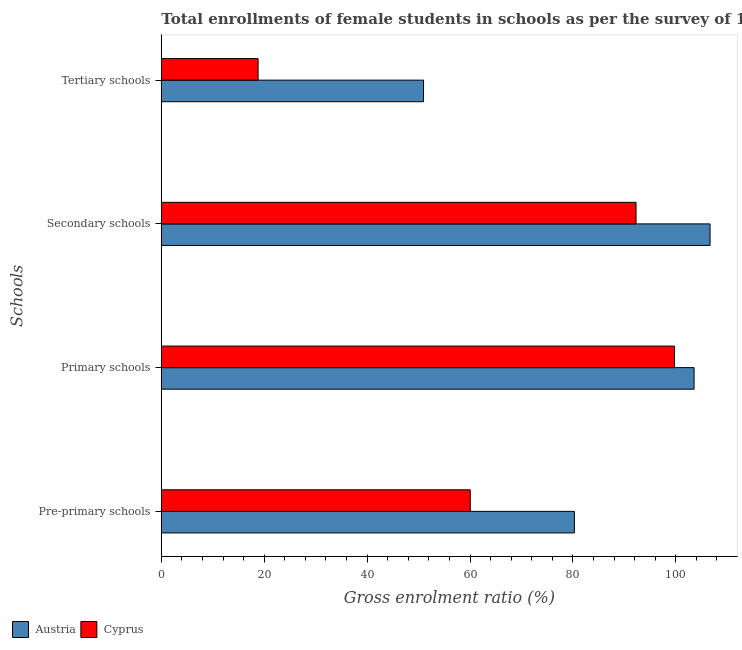How many different coloured bars are there?
Ensure brevity in your answer.  2. Are the number of bars per tick equal to the number of legend labels?
Give a very brief answer. Yes. Are the number of bars on each tick of the Y-axis equal?
Offer a terse response. Yes. What is the label of the 1st group of bars from the top?
Keep it short and to the point. Tertiary schools. What is the gross enrolment ratio(female) in tertiary schools in Cyprus?
Keep it short and to the point. 18.81. Across all countries, what is the maximum gross enrolment ratio(female) in tertiary schools?
Your answer should be very brief. 50.97. Across all countries, what is the minimum gross enrolment ratio(female) in pre-primary schools?
Your response must be concise. 60.05. In which country was the gross enrolment ratio(female) in tertiary schools minimum?
Your answer should be compact. Cyprus. What is the total gross enrolment ratio(female) in tertiary schools in the graph?
Your answer should be very brief. 69.78. What is the difference between the gross enrolment ratio(female) in secondary schools in Austria and that in Cyprus?
Provide a short and direct response. 14.38. What is the difference between the gross enrolment ratio(female) in primary schools in Austria and the gross enrolment ratio(female) in secondary schools in Cyprus?
Provide a short and direct response. 11.28. What is the average gross enrolment ratio(female) in pre-primary schools per country?
Keep it short and to the point. 70.17. What is the difference between the gross enrolment ratio(female) in primary schools and gross enrolment ratio(female) in pre-primary schools in Austria?
Offer a terse response. 23.26. What is the ratio of the gross enrolment ratio(female) in secondary schools in Cyprus to that in Austria?
Provide a short and direct response. 0.87. Is the gross enrolment ratio(female) in tertiary schools in Austria less than that in Cyprus?
Your response must be concise. No. Is the difference between the gross enrolment ratio(female) in secondary schools in Austria and Cyprus greater than the difference between the gross enrolment ratio(female) in pre-primary schools in Austria and Cyprus?
Make the answer very short. No. What is the difference between the highest and the second highest gross enrolment ratio(female) in pre-primary schools?
Your answer should be very brief. 20.24. What is the difference between the highest and the lowest gross enrolment ratio(female) in pre-primary schools?
Offer a very short reply. 20.24. What does the 1st bar from the top in Primary schools represents?
Provide a succinct answer. Cyprus. What does the 1st bar from the bottom in Tertiary schools represents?
Provide a succinct answer. Austria. Is it the case that in every country, the sum of the gross enrolment ratio(female) in pre-primary schools and gross enrolment ratio(female) in primary schools is greater than the gross enrolment ratio(female) in secondary schools?
Ensure brevity in your answer.  Yes. How many countries are there in the graph?
Make the answer very short. 2. Are the values on the major ticks of X-axis written in scientific E-notation?
Provide a short and direct response. No. Does the graph contain any zero values?
Your answer should be compact. No. How many legend labels are there?
Offer a terse response. 2. What is the title of the graph?
Offer a terse response. Total enrollments of female students in schools as per the survey of 1997 conducted in different countries. What is the label or title of the Y-axis?
Provide a succinct answer. Schools. What is the Gross enrolment ratio (%) in Austria in Pre-primary schools?
Keep it short and to the point. 80.29. What is the Gross enrolment ratio (%) in Cyprus in Pre-primary schools?
Keep it short and to the point. 60.05. What is the Gross enrolment ratio (%) of Austria in Primary schools?
Offer a very short reply. 103.56. What is the Gross enrolment ratio (%) of Cyprus in Primary schools?
Ensure brevity in your answer.  99.76. What is the Gross enrolment ratio (%) of Austria in Secondary schools?
Make the answer very short. 106.66. What is the Gross enrolment ratio (%) in Cyprus in Secondary schools?
Offer a terse response. 92.28. What is the Gross enrolment ratio (%) in Austria in Tertiary schools?
Provide a succinct answer. 50.97. What is the Gross enrolment ratio (%) in Cyprus in Tertiary schools?
Make the answer very short. 18.81. Across all Schools, what is the maximum Gross enrolment ratio (%) of Austria?
Your response must be concise. 106.66. Across all Schools, what is the maximum Gross enrolment ratio (%) of Cyprus?
Your answer should be compact. 99.76. Across all Schools, what is the minimum Gross enrolment ratio (%) in Austria?
Offer a terse response. 50.97. Across all Schools, what is the minimum Gross enrolment ratio (%) in Cyprus?
Offer a terse response. 18.81. What is the total Gross enrolment ratio (%) of Austria in the graph?
Provide a short and direct response. 341.47. What is the total Gross enrolment ratio (%) of Cyprus in the graph?
Keep it short and to the point. 270.89. What is the difference between the Gross enrolment ratio (%) of Austria in Pre-primary schools and that in Primary schools?
Ensure brevity in your answer.  -23.26. What is the difference between the Gross enrolment ratio (%) of Cyprus in Pre-primary schools and that in Primary schools?
Give a very brief answer. -39.71. What is the difference between the Gross enrolment ratio (%) in Austria in Pre-primary schools and that in Secondary schools?
Keep it short and to the point. -26.37. What is the difference between the Gross enrolment ratio (%) in Cyprus in Pre-primary schools and that in Secondary schools?
Provide a short and direct response. -32.23. What is the difference between the Gross enrolment ratio (%) of Austria in Pre-primary schools and that in Tertiary schools?
Your answer should be compact. 29.32. What is the difference between the Gross enrolment ratio (%) of Cyprus in Pre-primary schools and that in Tertiary schools?
Provide a short and direct response. 41.24. What is the difference between the Gross enrolment ratio (%) of Austria in Primary schools and that in Secondary schools?
Make the answer very short. -3.1. What is the difference between the Gross enrolment ratio (%) of Cyprus in Primary schools and that in Secondary schools?
Offer a very short reply. 7.48. What is the difference between the Gross enrolment ratio (%) in Austria in Primary schools and that in Tertiary schools?
Offer a very short reply. 52.59. What is the difference between the Gross enrolment ratio (%) of Cyprus in Primary schools and that in Tertiary schools?
Your answer should be very brief. 80.94. What is the difference between the Gross enrolment ratio (%) in Austria in Secondary schools and that in Tertiary schools?
Give a very brief answer. 55.69. What is the difference between the Gross enrolment ratio (%) of Cyprus in Secondary schools and that in Tertiary schools?
Offer a terse response. 73.46. What is the difference between the Gross enrolment ratio (%) in Austria in Pre-primary schools and the Gross enrolment ratio (%) in Cyprus in Primary schools?
Keep it short and to the point. -19.46. What is the difference between the Gross enrolment ratio (%) in Austria in Pre-primary schools and the Gross enrolment ratio (%) in Cyprus in Secondary schools?
Provide a succinct answer. -11.98. What is the difference between the Gross enrolment ratio (%) in Austria in Pre-primary schools and the Gross enrolment ratio (%) in Cyprus in Tertiary schools?
Give a very brief answer. 61.48. What is the difference between the Gross enrolment ratio (%) in Austria in Primary schools and the Gross enrolment ratio (%) in Cyprus in Secondary schools?
Keep it short and to the point. 11.28. What is the difference between the Gross enrolment ratio (%) of Austria in Primary schools and the Gross enrolment ratio (%) of Cyprus in Tertiary schools?
Your answer should be very brief. 84.74. What is the difference between the Gross enrolment ratio (%) in Austria in Secondary schools and the Gross enrolment ratio (%) in Cyprus in Tertiary schools?
Provide a short and direct response. 87.85. What is the average Gross enrolment ratio (%) in Austria per Schools?
Make the answer very short. 85.37. What is the average Gross enrolment ratio (%) in Cyprus per Schools?
Give a very brief answer. 67.72. What is the difference between the Gross enrolment ratio (%) of Austria and Gross enrolment ratio (%) of Cyprus in Pre-primary schools?
Your answer should be compact. 20.24. What is the difference between the Gross enrolment ratio (%) in Austria and Gross enrolment ratio (%) in Cyprus in Primary schools?
Offer a very short reply. 3.8. What is the difference between the Gross enrolment ratio (%) in Austria and Gross enrolment ratio (%) in Cyprus in Secondary schools?
Your answer should be very brief. 14.38. What is the difference between the Gross enrolment ratio (%) of Austria and Gross enrolment ratio (%) of Cyprus in Tertiary schools?
Your answer should be very brief. 32.15. What is the ratio of the Gross enrolment ratio (%) of Austria in Pre-primary schools to that in Primary schools?
Offer a terse response. 0.78. What is the ratio of the Gross enrolment ratio (%) of Cyprus in Pre-primary schools to that in Primary schools?
Your response must be concise. 0.6. What is the ratio of the Gross enrolment ratio (%) in Austria in Pre-primary schools to that in Secondary schools?
Keep it short and to the point. 0.75. What is the ratio of the Gross enrolment ratio (%) in Cyprus in Pre-primary schools to that in Secondary schools?
Make the answer very short. 0.65. What is the ratio of the Gross enrolment ratio (%) in Austria in Pre-primary schools to that in Tertiary schools?
Offer a very short reply. 1.58. What is the ratio of the Gross enrolment ratio (%) of Cyprus in Pre-primary schools to that in Tertiary schools?
Your answer should be very brief. 3.19. What is the ratio of the Gross enrolment ratio (%) in Austria in Primary schools to that in Secondary schools?
Offer a terse response. 0.97. What is the ratio of the Gross enrolment ratio (%) in Cyprus in Primary schools to that in Secondary schools?
Provide a short and direct response. 1.08. What is the ratio of the Gross enrolment ratio (%) in Austria in Primary schools to that in Tertiary schools?
Make the answer very short. 2.03. What is the ratio of the Gross enrolment ratio (%) in Cyprus in Primary schools to that in Tertiary schools?
Keep it short and to the point. 5.3. What is the ratio of the Gross enrolment ratio (%) in Austria in Secondary schools to that in Tertiary schools?
Offer a very short reply. 2.09. What is the ratio of the Gross enrolment ratio (%) of Cyprus in Secondary schools to that in Tertiary schools?
Keep it short and to the point. 4.9. What is the difference between the highest and the second highest Gross enrolment ratio (%) of Austria?
Ensure brevity in your answer.  3.1. What is the difference between the highest and the second highest Gross enrolment ratio (%) in Cyprus?
Make the answer very short. 7.48. What is the difference between the highest and the lowest Gross enrolment ratio (%) of Austria?
Keep it short and to the point. 55.69. What is the difference between the highest and the lowest Gross enrolment ratio (%) of Cyprus?
Your answer should be compact. 80.94. 